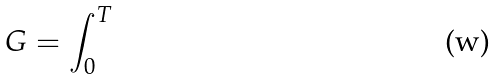<formula> <loc_0><loc_0><loc_500><loc_500>G = \int _ { 0 } ^ { T }</formula> 